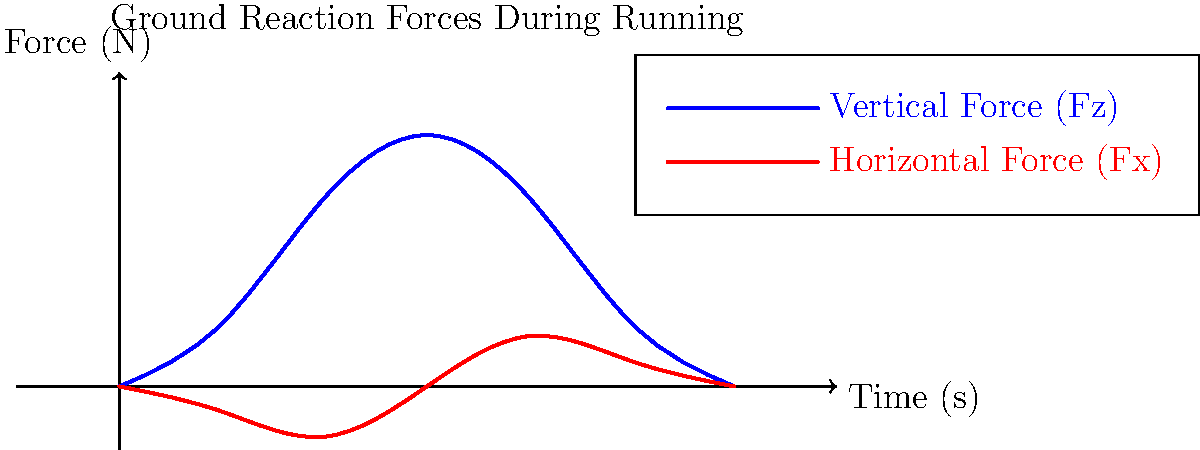In the graph of ground reaction forces during running, what does the intersection point of the vertical force (Fz) and horizontal force (Fx) curves represent in terms of the runner's gait cycle? To understand what the intersection point represents, let's analyze the graph step-by-step:

1. The blue curve represents the vertical force (Fz), which shows the typical double-peak pattern of ground reaction force during running.

2. The red curve represents the horizontal force (Fx), which shows braking (negative values) and propulsion (positive values) forces.

3. The intersection point occurs at approximately 0.15 seconds into the stance phase.

4. At this point:
   a) The vertical force (Fz) is near its maximum, indicating mid-stance.
   b) The horizontal force (Fx) transitions from negative (braking) to positive (propulsion).

5. In the running gait cycle, this moment represents the transition from the braking phase to the propulsion phase.

6. Biomechanically, this is when the runner's center of mass is directly over the point of ground contact.

7. This instant is often referred to as the "zero point" or "mid-stance" in running analyses.

8. It's a crucial moment for energy transfer and redistribution in the running gait cycle.

The intersection point, therefore, represents the moment of transition from braking to propulsion in the runner's stance phase, coinciding with mid-stance when the center of mass is over the point of ground contact.
Answer: Mid-stance transition from braking to propulsion 